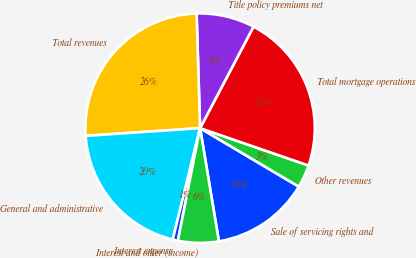Convert chart. <chart><loc_0><loc_0><loc_500><loc_500><pie_chart><fcel>Sale of servicing rights and<fcel>Other revenues<fcel>Total mortgage operations<fcel>Title policy premiums net<fcel>Total revenues<fcel>General and administrative<fcel>Interest expense<fcel>Interest and other (income)<nl><fcel>13.87%<fcel>3.23%<fcel>22.57%<fcel>8.2%<fcel>25.59%<fcel>20.09%<fcel>0.74%<fcel>5.71%<nl></chart> 